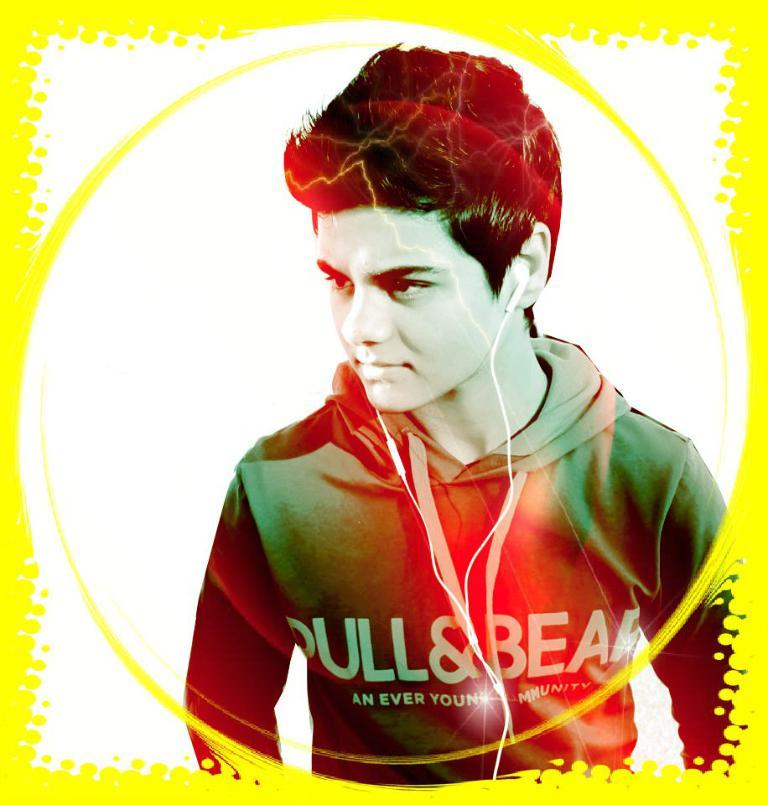Provide a one-sentence caption for the provided image. A boy wearing a sweatshirt that says Bull & Bear. 